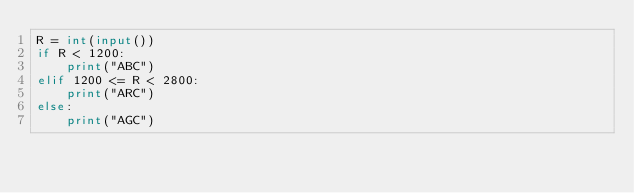<code> <loc_0><loc_0><loc_500><loc_500><_Python_>R = int(input())
if R < 1200:
    print("ABC")
elif 1200 <= R < 2800:
    print("ARC")
else:
    print("AGC")
</code> 